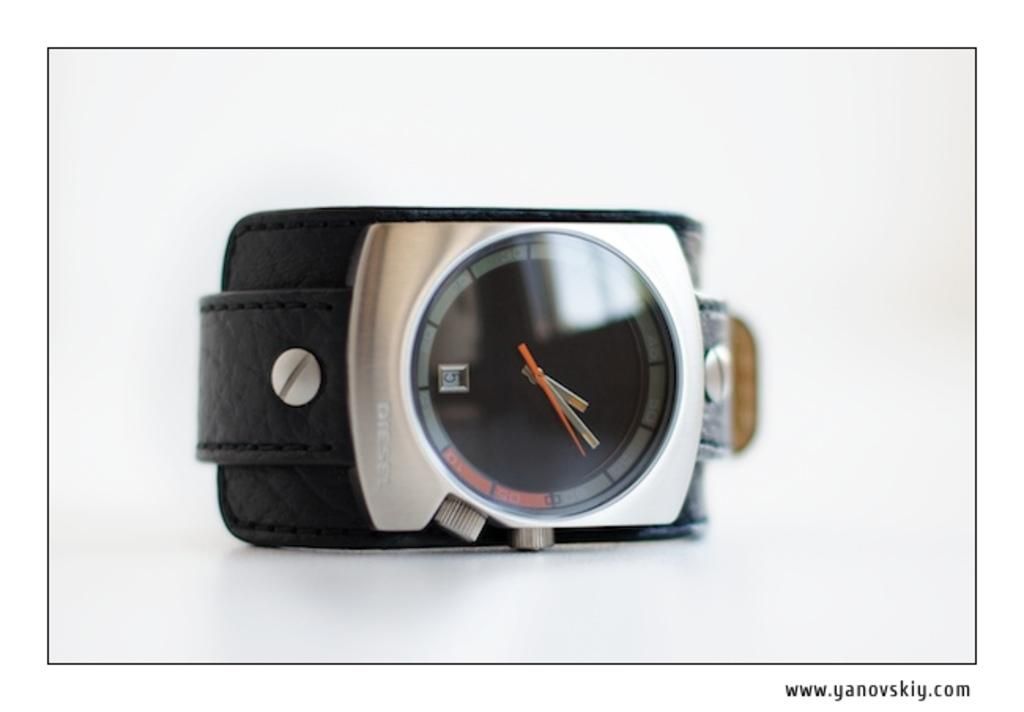<image>
Write a terse but informative summary of the picture. A photo of a modern looking watch is on www.yanovskiy.com 